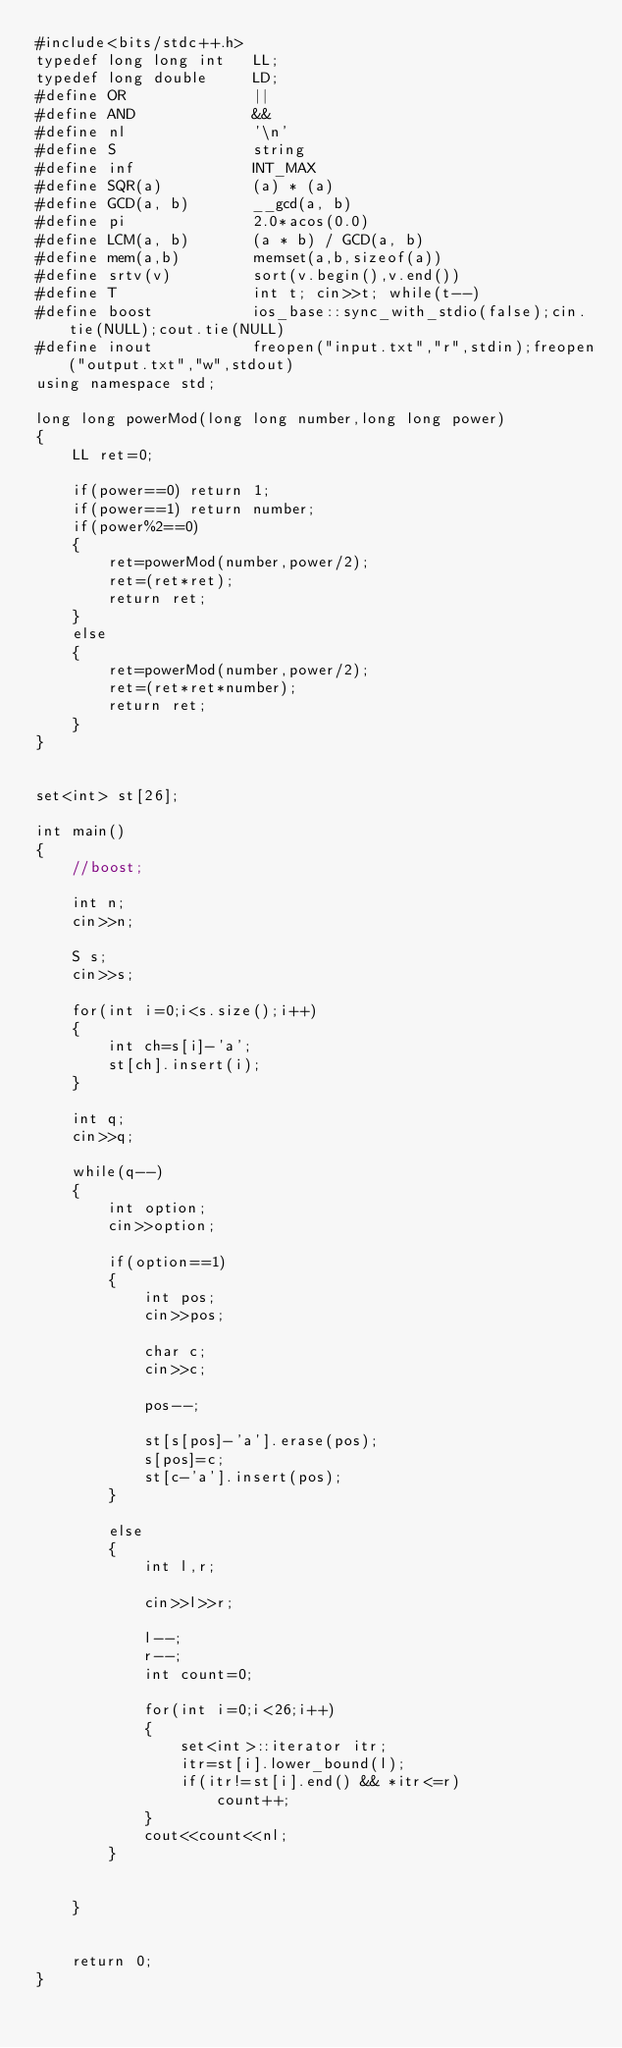Convert code to text. <code><loc_0><loc_0><loc_500><loc_500><_C++_>#include<bits/stdc++.h>
typedef long long int   LL;
typedef long double     LD;
#define OR              ||
#define AND             &&
#define nl              '\n'
#define S               string
#define inf             INT_MAX
#define SQR(a)          (a) * (a)
#define GCD(a, b)       __gcd(a, b)
#define pi              2.0*acos(0.0)
#define LCM(a, b)       (a * b) / GCD(a, b)
#define mem(a,b)        memset(a,b,sizeof(a))
#define srtv(v)         sort(v.begin(),v.end())
#define T               int t; cin>>t; while(t--)
#define boost		    ios_base::sync_with_stdio(false);cin.tie(NULL);cout.tie(NULL)
#define inout           freopen("input.txt","r",stdin);freopen("output.txt","w",stdout)
using namespace std;

long long powerMod(long long number,long long power)
{
    LL ret=0;

    if(power==0) return 1;
    if(power==1) return number;
    if(power%2==0)
    {
        ret=powerMod(number,power/2);
        ret=(ret*ret);
        return ret;
    }
    else
    {
        ret=powerMod(number,power/2);
        ret=(ret*ret*number);
        return ret;
    }
}


set<int> st[26];

int main()
{
    //boost;

    int n;
    cin>>n;

    S s;
    cin>>s;

    for(int i=0;i<s.size();i++)
    {
        int ch=s[i]-'a';
        st[ch].insert(i);
    }

    int q;
    cin>>q;

    while(q--)
    {
        int option;
        cin>>option;

        if(option==1)
        {
            int pos;
            cin>>pos;

            char c;
            cin>>c;

            pos--;

            st[s[pos]-'a'].erase(pos);
            s[pos]=c;
            st[c-'a'].insert(pos);
        }

        else
        {
            int l,r;

            cin>>l>>r;

            l--;
            r--;
            int count=0;

            for(int i=0;i<26;i++)
            {
                set<int>::iterator itr;
                itr=st[i].lower_bound(l);
                if(itr!=st[i].end() && *itr<=r)
                    count++;
            }
            cout<<count<<nl;
        }


    }


    return 0;
}
</code> 